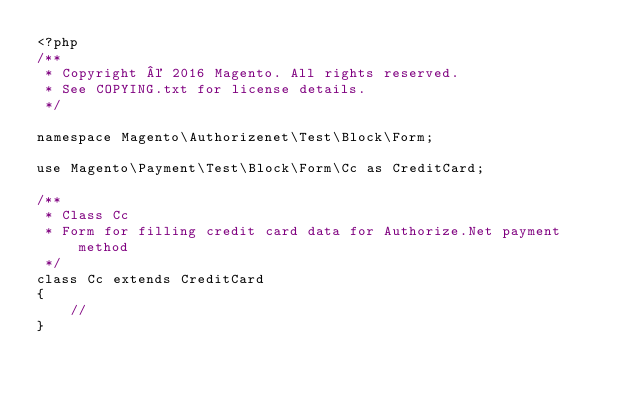Convert code to text. <code><loc_0><loc_0><loc_500><loc_500><_PHP_><?php
/**
 * Copyright © 2016 Magento. All rights reserved.
 * See COPYING.txt for license details.
 */

namespace Magento\Authorizenet\Test\Block\Form;

use Magento\Payment\Test\Block\Form\Cc as CreditCard;

/**
 * Class Cc
 * Form for filling credit card data for Authorize.Net payment method
 */
class Cc extends CreditCard
{
    //
}
</code> 